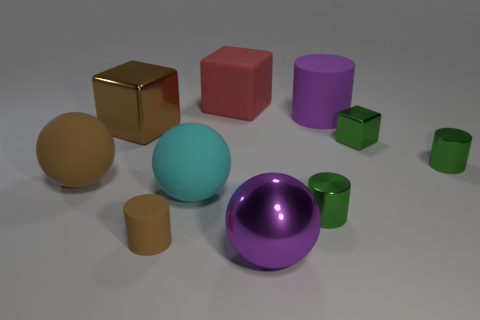What number of other things are there of the same shape as the tiny matte thing?
Offer a terse response. 3. There is a tiny shiny object that is on the right side of the small green cube; is its shape the same as the red matte object?
Ensure brevity in your answer.  No. There is a large red object; are there any large red objects in front of it?
Your answer should be compact. No. How many big objects are purple spheres or green matte balls?
Keep it short and to the point. 1. Is the material of the large cyan thing the same as the brown block?
Provide a short and direct response. No. There is a cylinder that is the same color as the large metallic sphere; what is its size?
Provide a succinct answer. Large. Is there a matte cube that has the same color as the large rubber cylinder?
Give a very brief answer. No. There is a purple thing that is the same material as the small green block; what size is it?
Offer a very short reply. Large. There is a thing behind the large purple object right of the metal cylinder that is in front of the large brown matte ball; what is its shape?
Your answer should be very brief. Cube. What size is the green thing that is the same shape as the large brown metallic thing?
Offer a terse response. Small. 